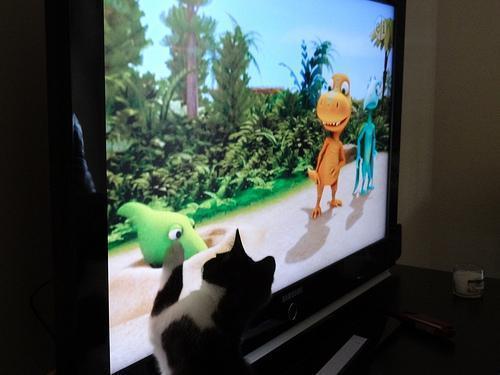How many cats are there?
Give a very brief answer. 1. 